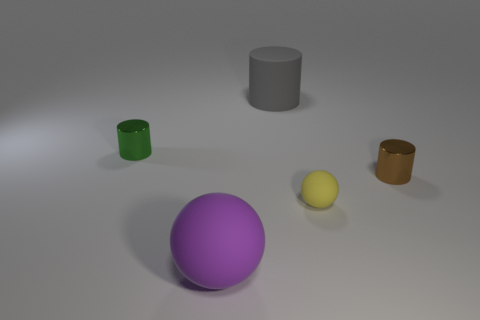Subtract all green cylinders. How many cylinders are left? 2 Subtract 1 cylinders. How many cylinders are left? 2 Subtract all spheres. How many objects are left? 3 Add 1 yellow objects. How many objects exist? 6 Subtract 0 green cubes. How many objects are left? 5 Subtract all blue cylinders. Subtract all green blocks. How many cylinders are left? 3 Subtract all big purple shiny objects. Subtract all big matte cylinders. How many objects are left? 4 Add 3 green metallic cylinders. How many green metallic cylinders are left? 4 Add 5 tiny yellow rubber blocks. How many tiny yellow rubber blocks exist? 5 